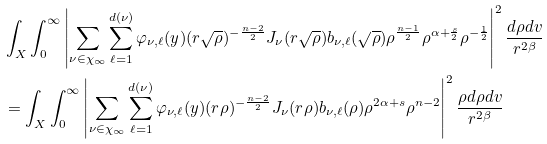<formula> <loc_0><loc_0><loc_500><loc_500>& \int _ { X } \int _ { 0 } ^ { \infty } \left | \sum _ { \nu \in \chi _ { \infty } } \sum _ { \ell = 1 } ^ { d ( \nu ) } \varphi _ { \nu , \ell } ( y ) ( r \sqrt { \rho } ) ^ { - \frac { n - 2 } 2 } J _ { \nu } ( r \sqrt { \rho } ) b _ { \nu , \ell } ( \sqrt { \rho } ) \rho ^ { \frac { n - 1 } 2 } \rho ^ { \alpha + \frac { s } { 2 } } \rho ^ { - \frac { 1 } { 2 } } \right | ^ { 2 } \frac { d \rho d v } { r ^ { 2 \beta } } \\ & = \int _ { X } \int _ { 0 } ^ { \infty } \left | \sum _ { \nu \in \chi _ { \infty } } \sum _ { \ell = 1 } ^ { d ( \nu ) } \varphi _ { \nu , \ell } ( y ) ( r \rho ) ^ { - \frac { n - 2 } 2 } J _ { \nu } ( r \rho ) b _ { \nu , \ell } ( \rho ) \rho ^ { 2 \alpha + s } \rho ^ { n - 2 } \right | ^ { 2 } \frac { \rho d \rho d v } { r ^ { 2 \beta } }</formula> 